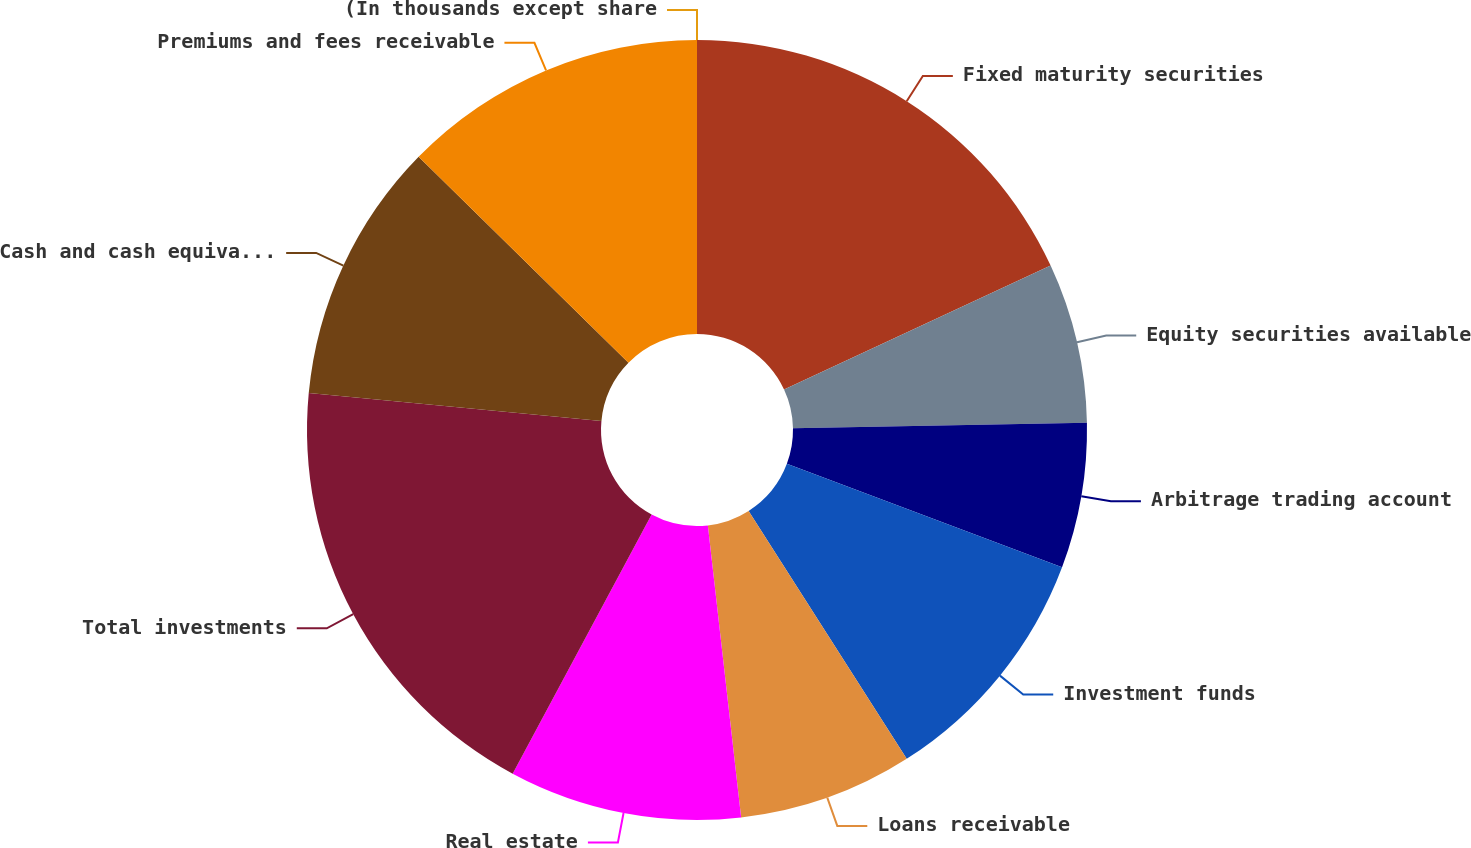<chart> <loc_0><loc_0><loc_500><loc_500><pie_chart><fcel>(In thousands except share<fcel>Fixed maturity securities<fcel>Equity securities available<fcel>Arbitrage trading account<fcel>Investment funds<fcel>Loans receivable<fcel>Real estate<fcel>Total investments<fcel>Cash and cash equivalents<fcel>Premiums and fees receivable<nl><fcel>0.0%<fcel>18.07%<fcel>6.63%<fcel>6.02%<fcel>10.24%<fcel>7.23%<fcel>9.64%<fcel>18.67%<fcel>10.84%<fcel>12.65%<nl></chart> 